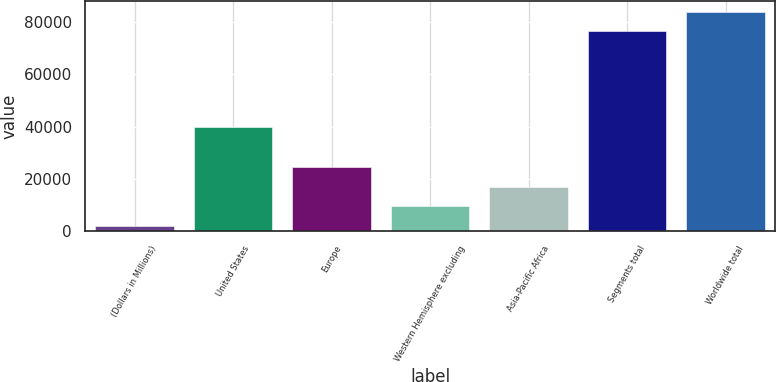<chart> <loc_0><loc_0><loc_500><loc_500><bar_chart><fcel>(Dollars in Millions)<fcel>United States<fcel>Europe<fcel>Western Hemisphere excluding<fcel>Asia-Pacific Africa<fcel>Segments total<fcel>Worldwide total<nl><fcel>2017<fcel>39863<fcel>24346.9<fcel>9460.3<fcel>16903.6<fcel>76450<fcel>83893.3<nl></chart> 